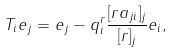Convert formula to latex. <formula><loc_0><loc_0><loc_500><loc_500>T _ { i } e _ { j } = e _ { j } - q _ { i } ^ { r } \frac { [ r a _ { j i } ] _ { j } } { [ r ] _ { j } } e _ { i } ,</formula> 